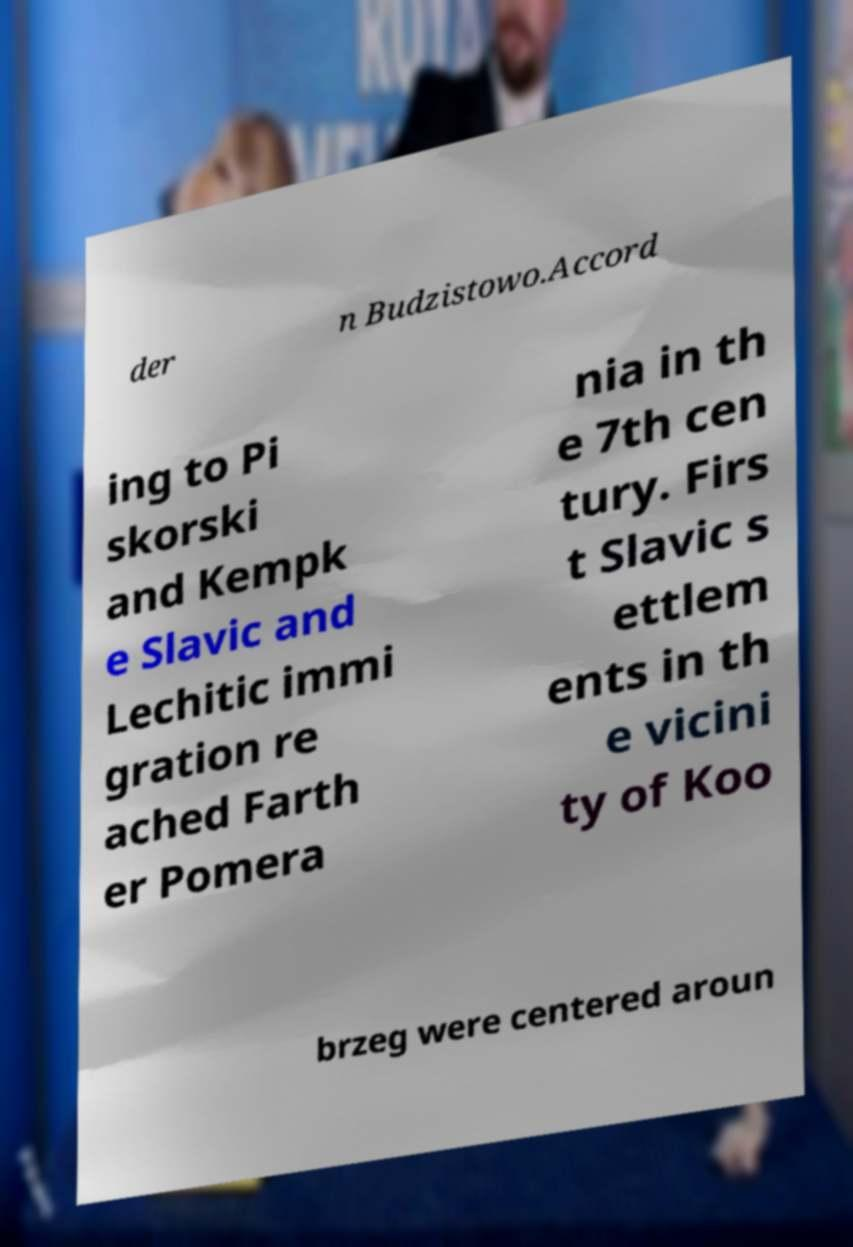Can you accurately transcribe the text from the provided image for me? der n Budzistowo.Accord ing to Pi skorski and Kempk e Slavic and Lechitic immi gration re ached Farth er Pomera nia in th e 7th cen tury. Firs t Slavic s ettlem ents in th e vicini ty of Koo brzeg were centered aroun 